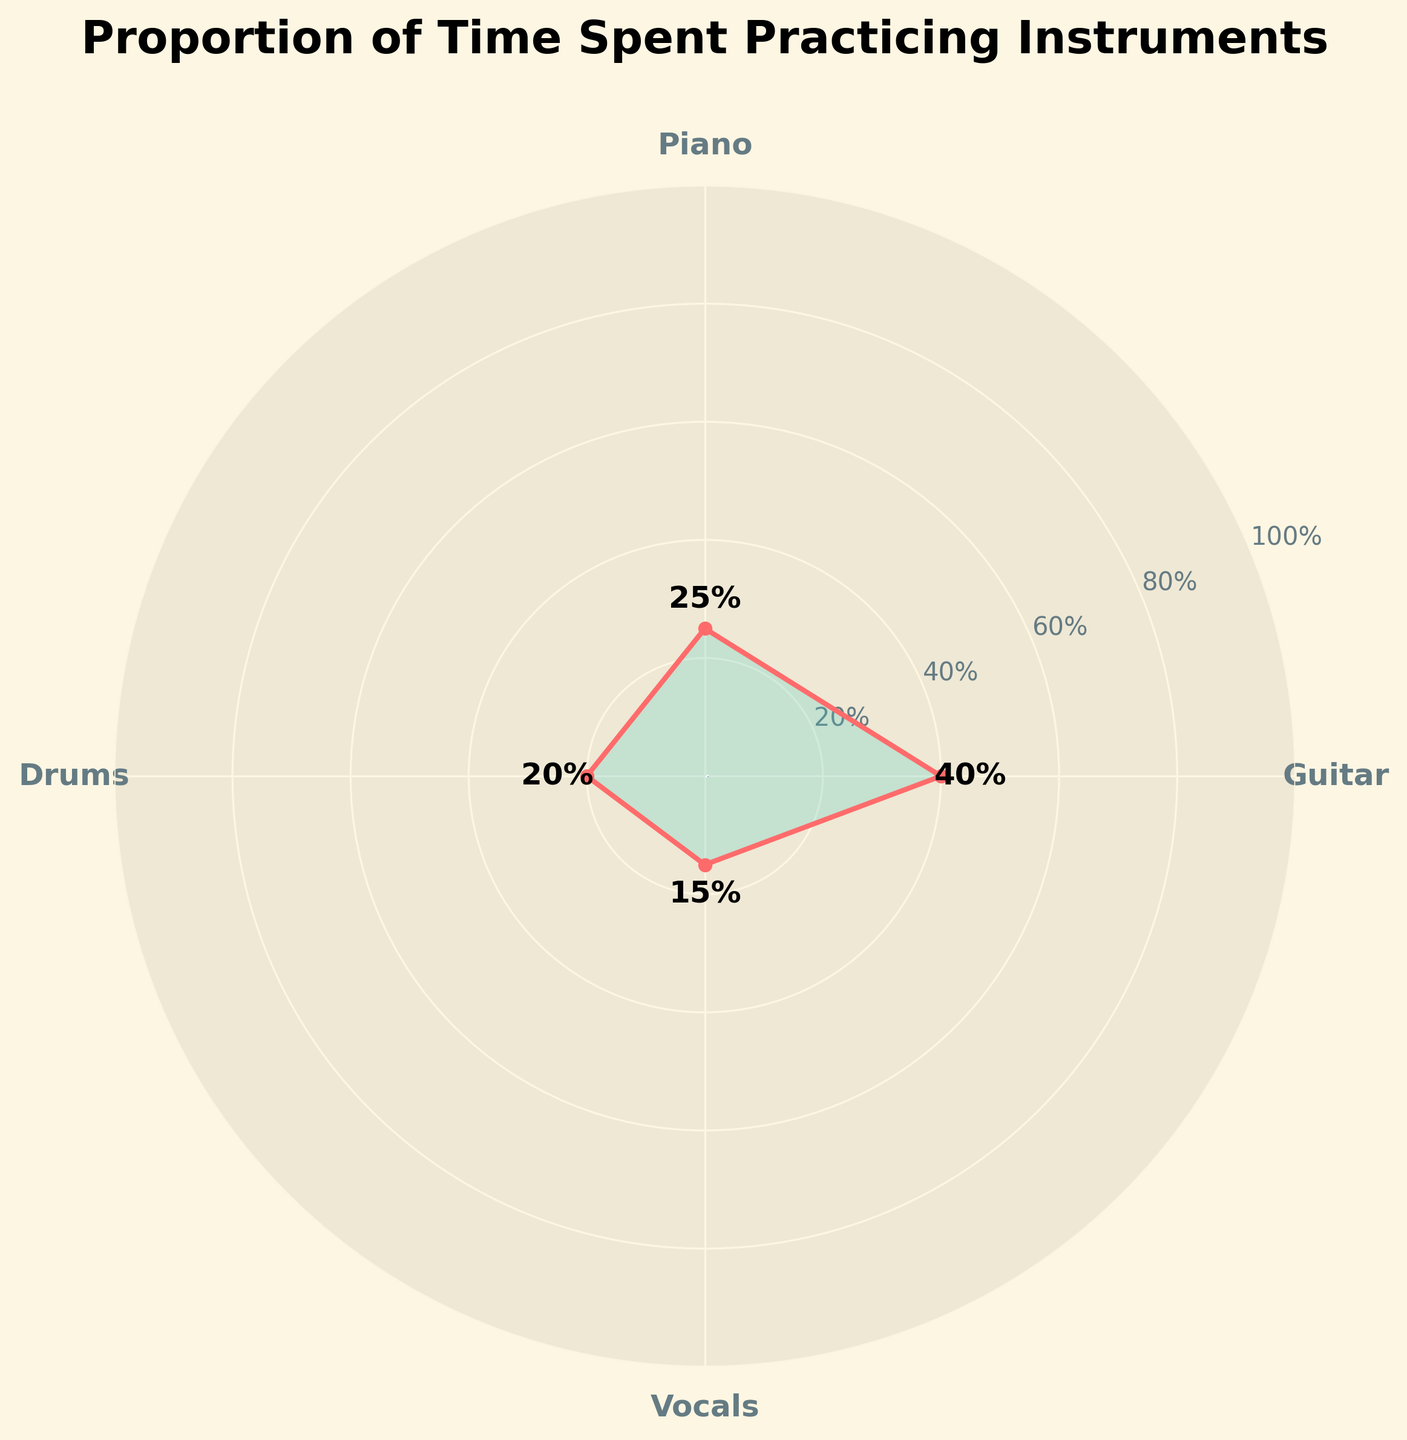Which instrument do I spend the most time practicing? The figure shows the different proportions of time spent on each instrument. By observing the plot, you can see that the Guitar has the largest percentage at 40%.
Answer: Guitar What is the total percentage of time spent practicing Drums and Vocals? To find the total percentage, add the proportions of time spent on Drums (20%) and Vocals (15%). 20% + 15% = 35%.
Answer: 35% Which instrument do I spend the least time practicing? By examining the figure, Vocals have the smallest percentage at 15%.
Answer: Vocals How much more time do I spend practicing Guitar compared to Piano? Subtract the percentage of time spent on Piano (25%) from the percentage of time spent on Guitar (40%). 40% - 25% = 15%.
Answer: 15% What is the combined percentage of time spent practicing Guitar and Piano? Add the proportions of time spent on Guitar (40%) and Piano (25%). 40% + 25% = 65%.
Answer: 65% Is the time spent on Guitar greater than the combined time spent on Drums and Vocals? The time spent on Guitar is 40%. The combined time for Drums (20%) and Vocals (15%) is 35%. Since 40% > 35%, the time spent on Guitar is greater.
Answer: Yes What is the approximate average percentage of time spent on all the instruments? To find the average, add the percentages of all instruments and divide by the number of instruments: (40% + 25% + 20% + 15%) / 4 = 25%.
Answer: 25% Which two instruments have the closest time spent in practice? Comparing the percentages, Piano (25%) and Drums (20%) have the smallest difference of 5%.
Answer: Piano and Drums What is the title of the figure? The title of the figure is positioned at the top and reads "Proportion of Time Spent Practicing Instruments."
Answer: Proportion of Time Spent Practicing Instruments How many instruments are represented in the figure? The figure shows four different instruments represented by labels and segments on the chart: Guitar, Piano, Drums, and Vocals.
Answer: Four 